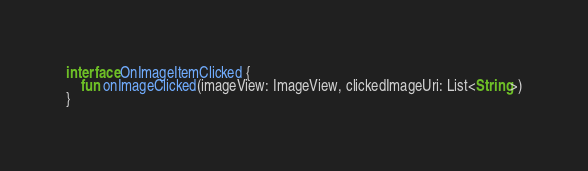Convert code to text. <code><loc_0><loc_0><loc_500><loc_500><_Kotlin_>interface OnImageItemClicked {
    fun onImageClicked(imageView: ImageView, clickedImageUri: List<String>)
}</code> 